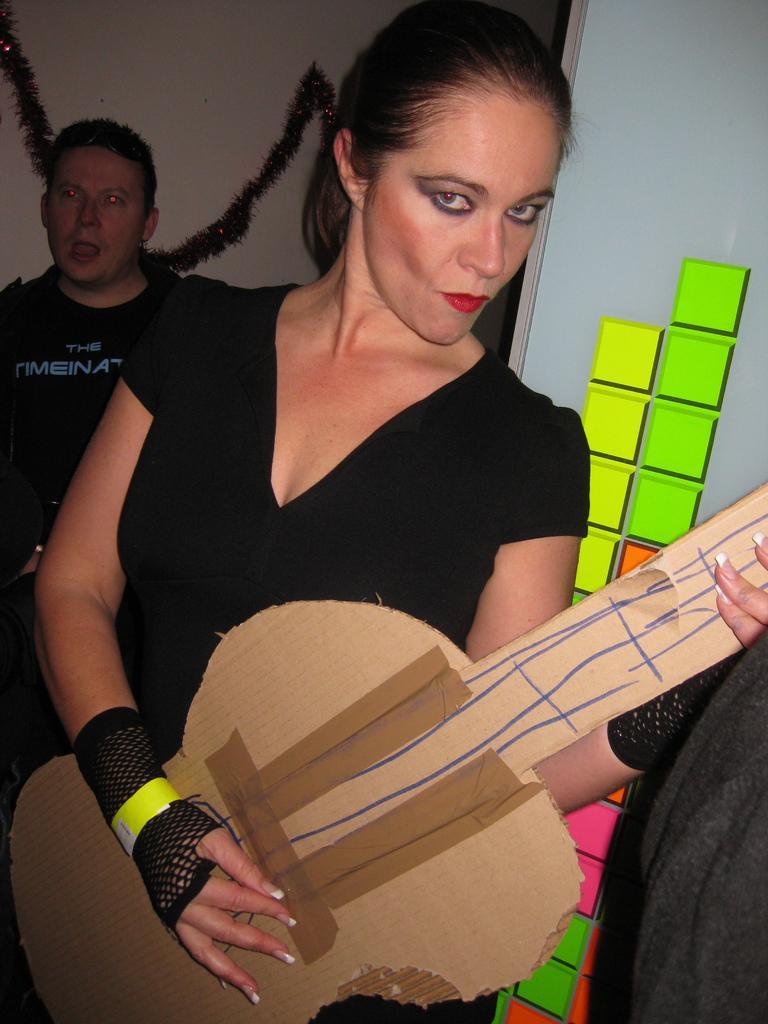Describe this image in one or two sentences. In this image I can see two persons standing. In front the person is holding the cardboard sheet which is in the shape of guitar and the person is wearing black color dress. In the background the wall is in white color. 